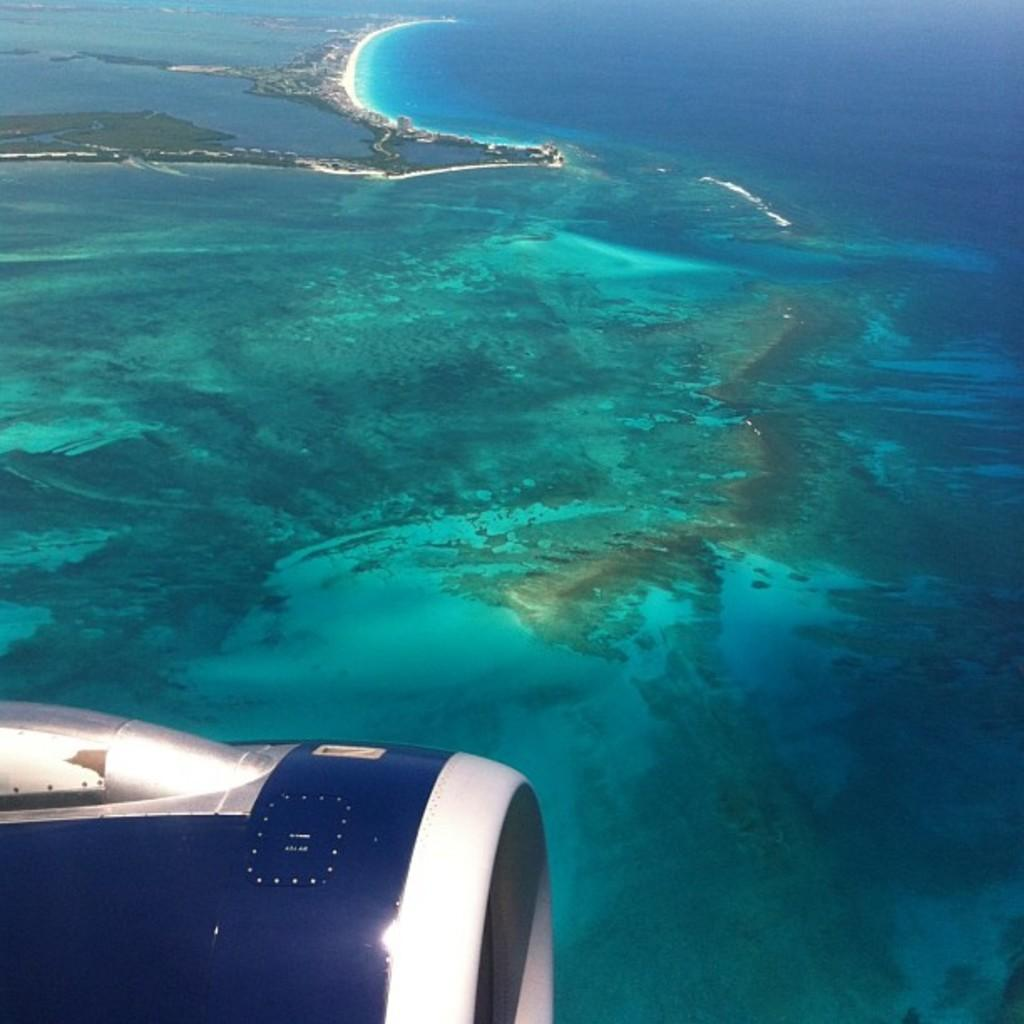What is the perspective of the image? The image is taken from a plane. What part of the plane can be seen in the image? The propeller of the plane is visible in the left bottom of the image. What type of landscape is shown at the bottom of the image? There is a sea at the bottom of the image. What is the primary element present in the image? The image contains water. How many feet are visible in the image? There are no feet visible in the image. What type of vessel is present in the image? There is no vessel present in the image. 